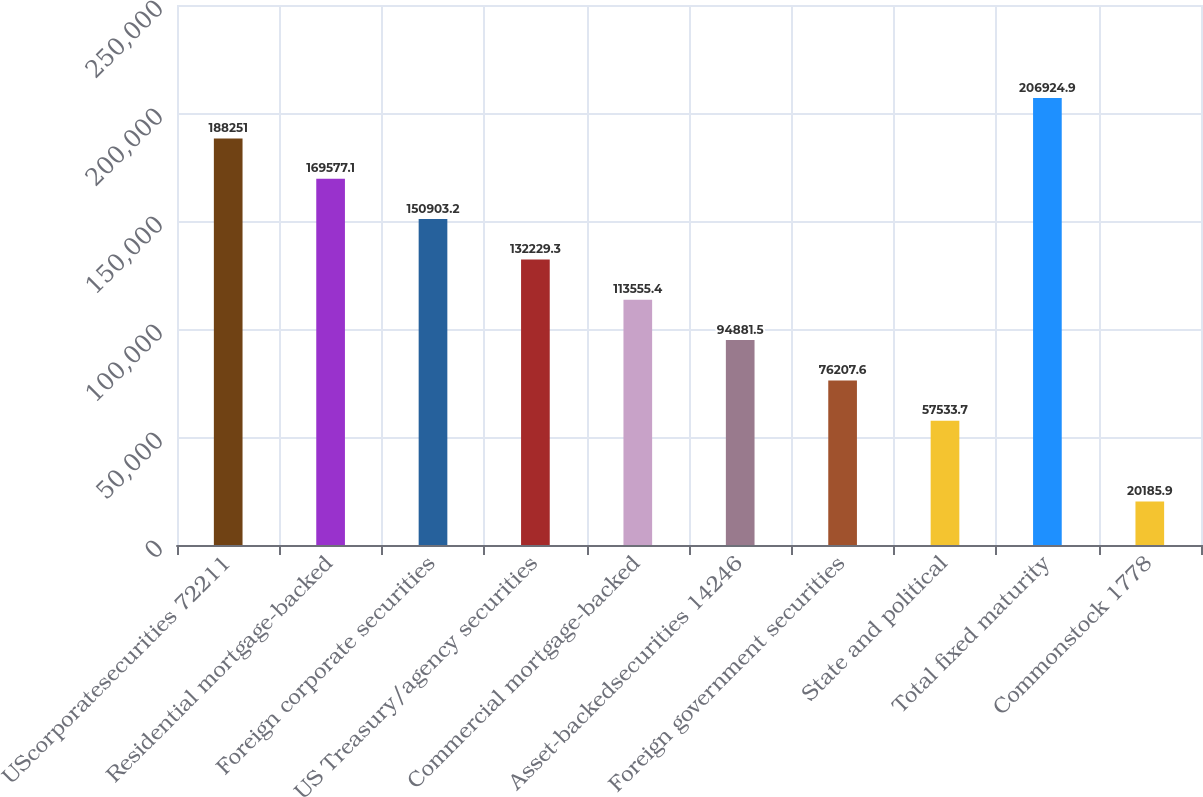Convert chart. <chart><loc_0><loc_0><loc_500><loc_500><bar_chart><fcel>UScorporatesecurities 72211<fcel>Residential mortgage-backed<fcel>Foreign corporate securities<fcel>US Treasury/agency securities<fcel>Commercial mortgage-backed<fcel>Asset-backedsecurities 14246<fcel>Foreign government securities<fcel>State and political<fcel>Total fixed maturity<fcel>Commonstock 1778<nl><fcel>188251<fcel>169577<fcel>150903<fcel>132229<fcel>113555<fcel>94881.5<fcel>76207.6<fcel>57533.7<fcel>206925<fcel>20185.9<nl></chart> 